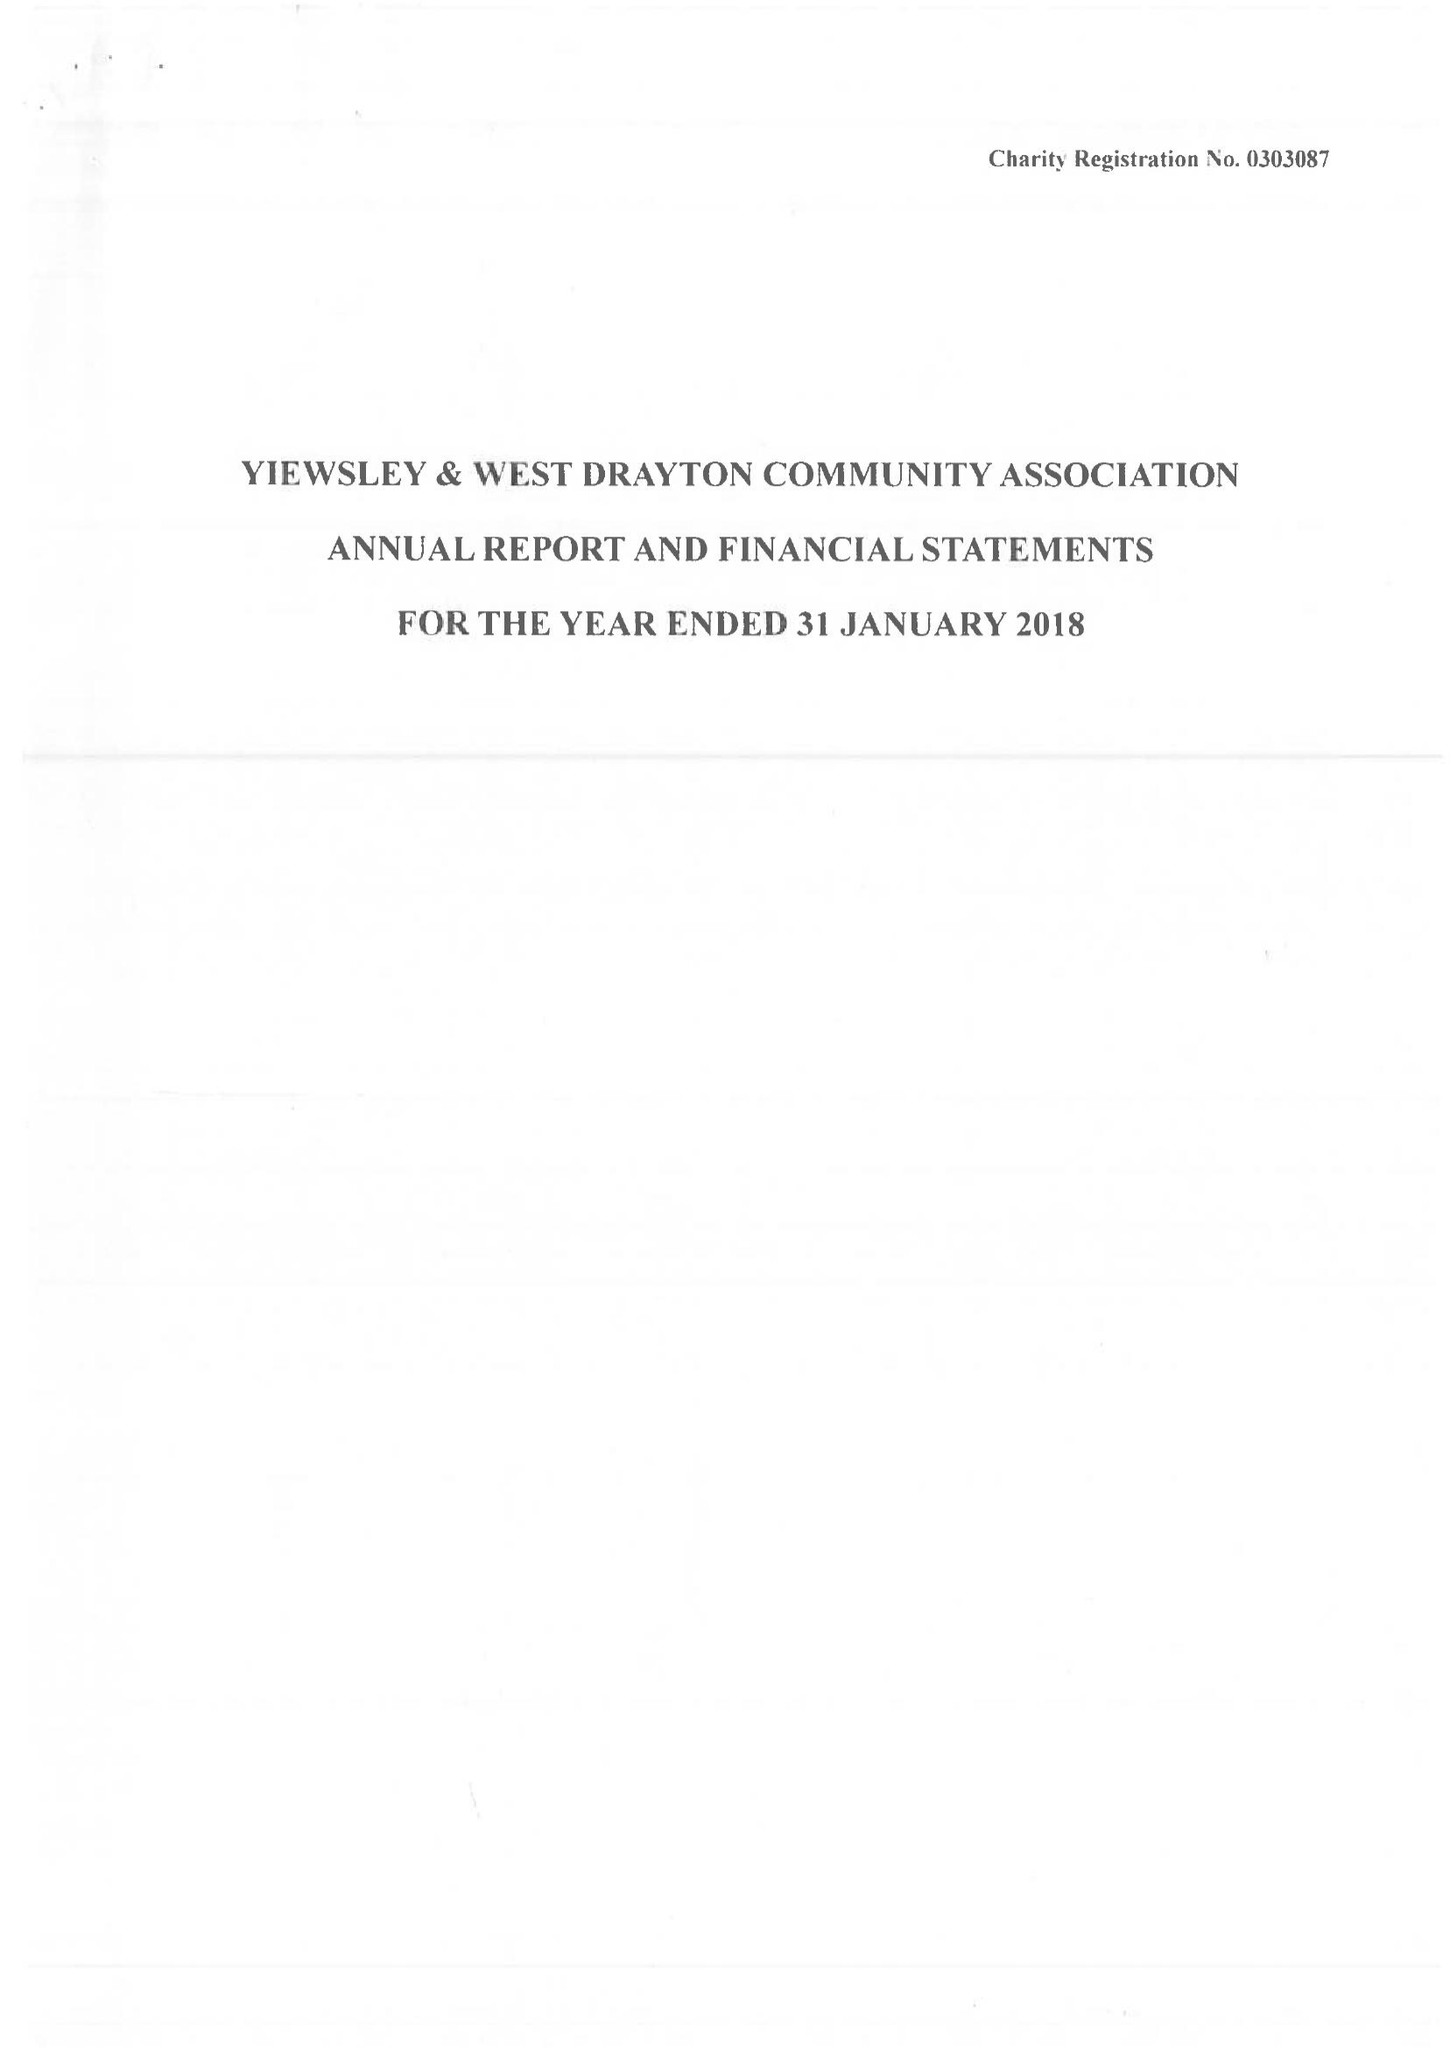What is the value for the address__post_town?
Answer the question using a single word or phrase. WEST DRAYTON 